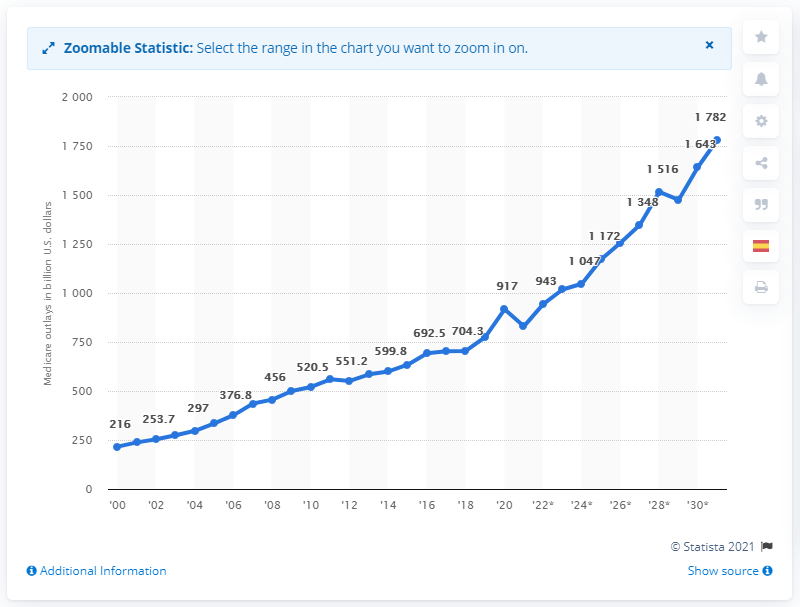Specify some key components in this picture. In the year 2020, the amount of Medicare outlays in the United States was $917. The projected increase in Medicare outlays for the year 2031 is expected to be 1,782. 